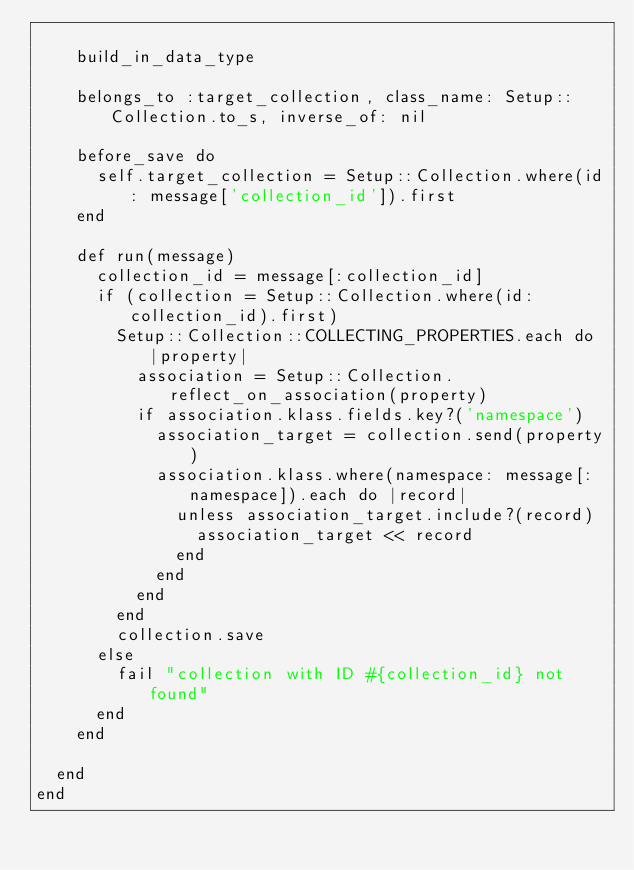<code> <loc_0><loc_0><loc_500><loc_500><_Ruby_>
    build_in_data_type

    belongs_to :target_collection, class_name: Setup::Collection.to_s, inverse_of: nil

    before_save do
      self.target_collection = Setup::Collection.where(id: message['collection_id']).first
    end

    def run(message)
      collection_id = message[:collection_id]
      if (collection = Setup::Collection.where(id: collection_id).first)
        Setup::Collection::COLLECTING_PROPERTIES.each do |property|
          association = Setup::Collection.reflect_on_association(property)
          if association.klass.fields.key?('namespace')
            association_target = collection.send(property)
            association.klass.where(namespace: message[:namespace]).each do |record|
              unless association_target.include?(record)
                association_target << record
              end
            end
          end
        end
        collection.save
      else
        fail "collection with ID #{collection_id} not found"
      end
    end

  end
end
</code> 